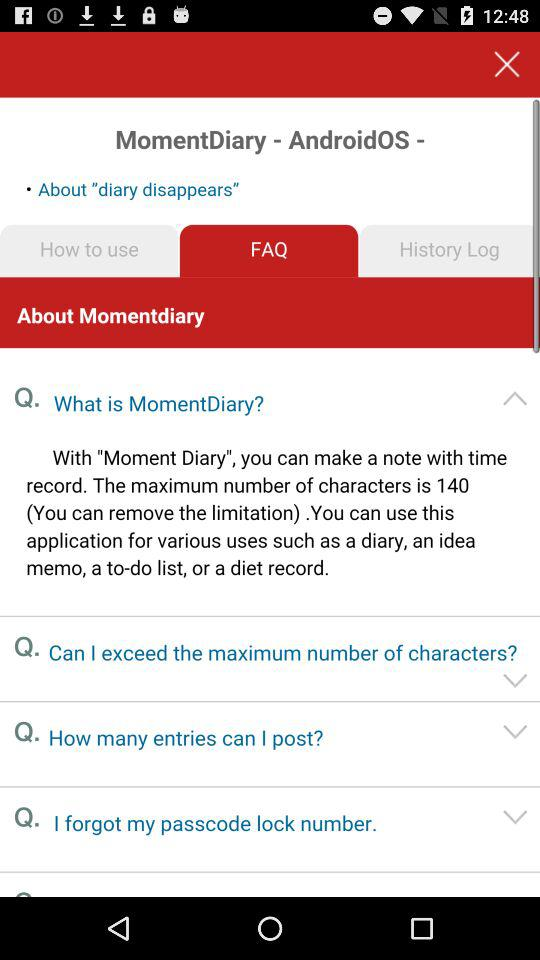What is written in "History Log"?
When the provided information is insufficient, respond with <no answer>. <no answer> 